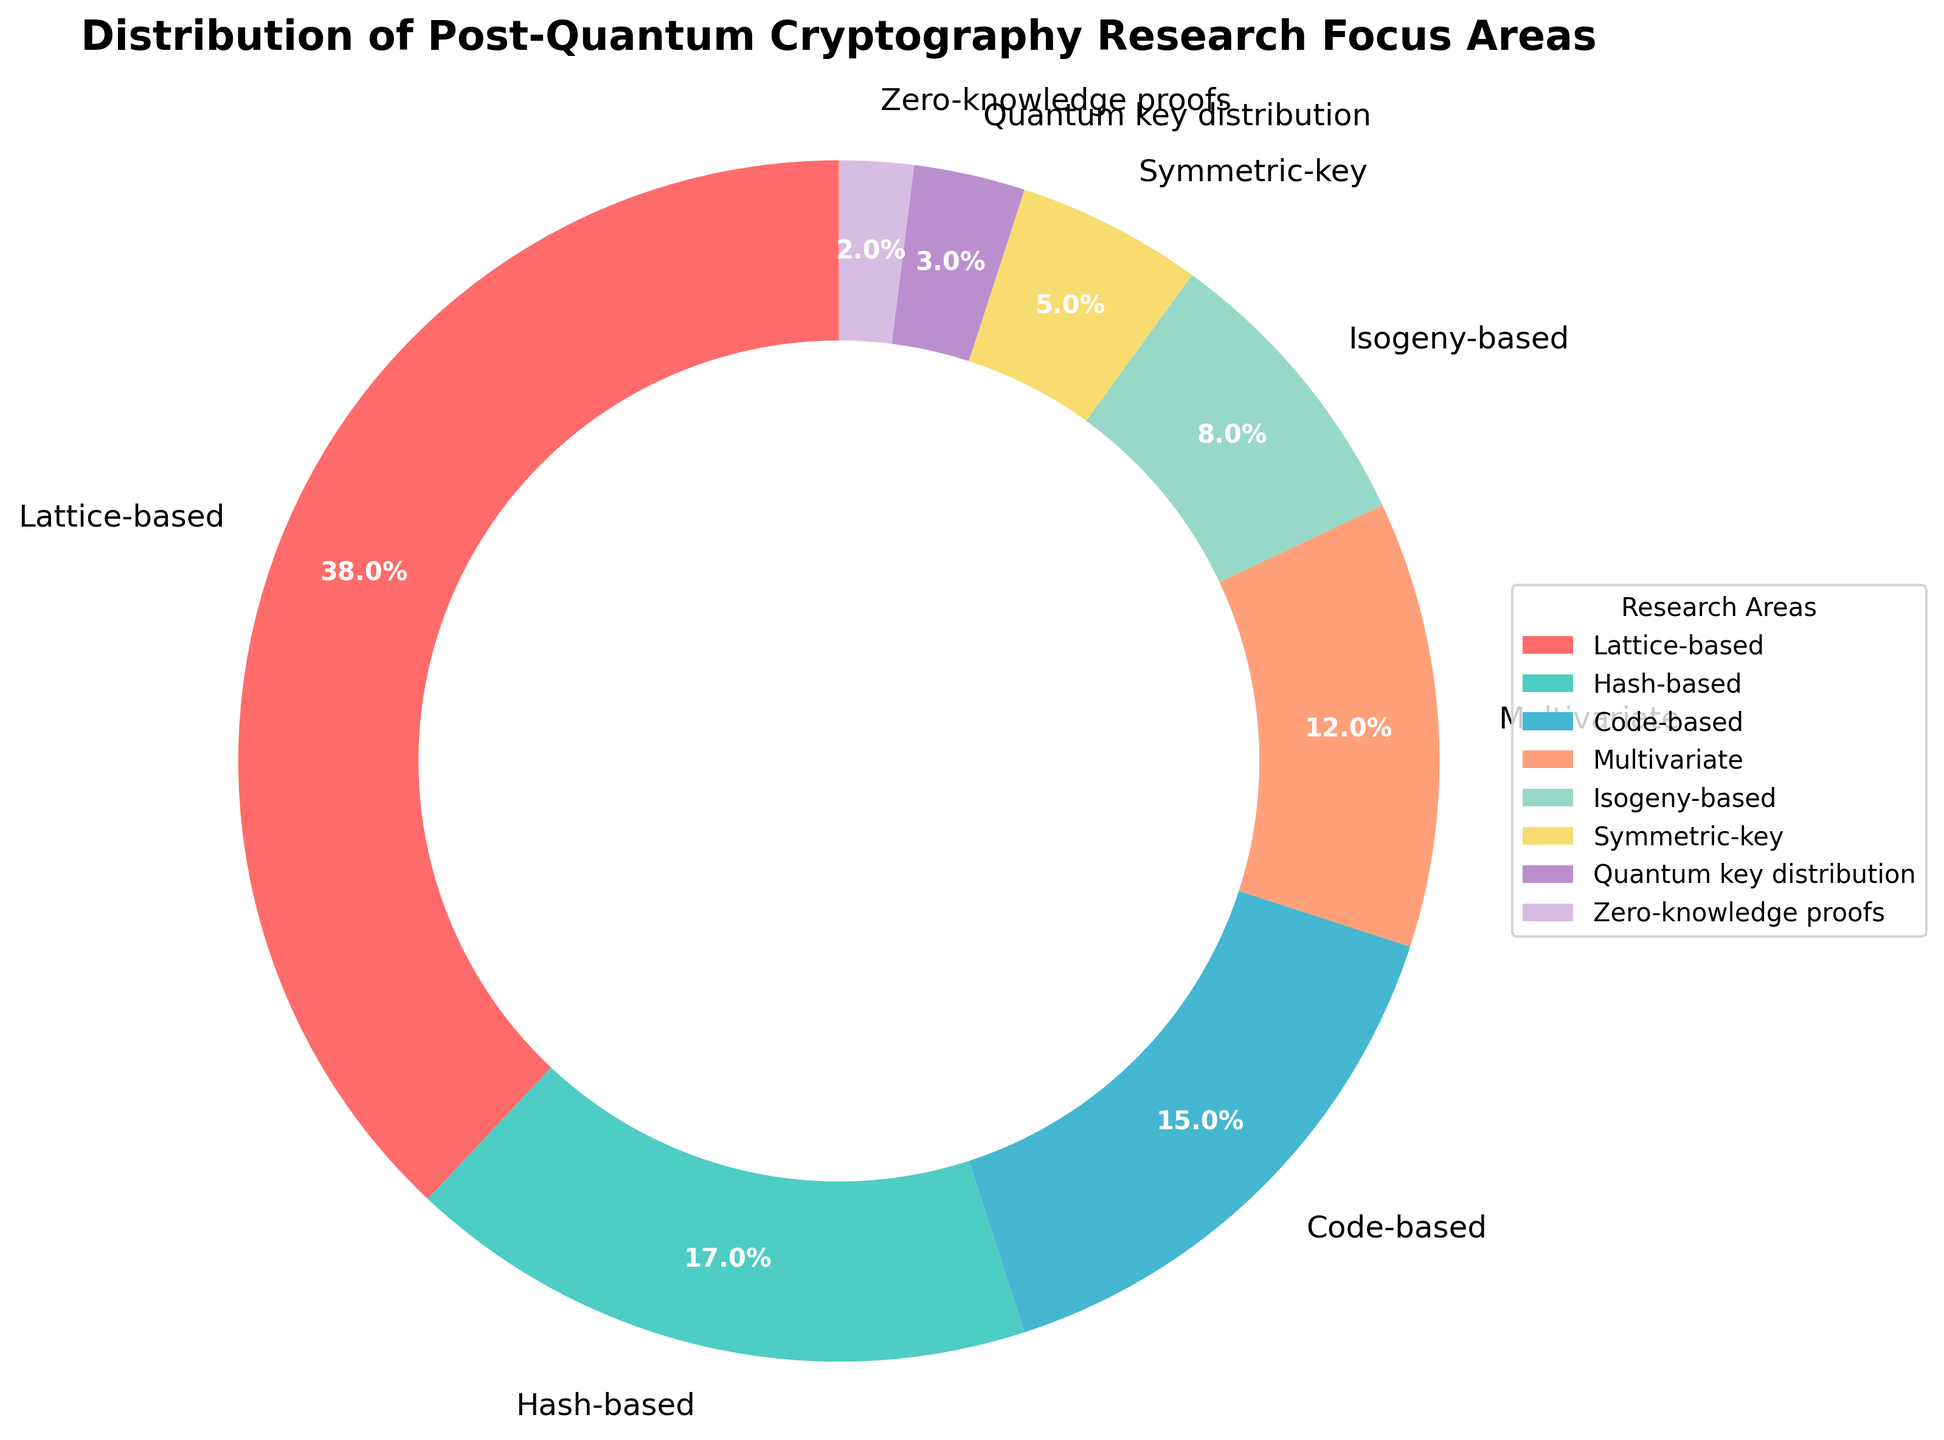What percentage of the research focus is dedicated to lattice-based cryptography? The pie chart shows that lattice-based cryptography accounts for 38% of the research focus.
Answer: 38% Which research area has a higher percentage focus, code-based or hash-based cryptography? By comparing the percentages, we see that hash-based cryptography (17%) has a higher percentage focus than code-based cryptography (15%).
Answer: Hash-based What is the combined research focus percentage of multivariate and isogeny-based approaches? The pie chart indicates that multivariate accounts for 12% and isogeny-based for 8%. Adding these together, 12% + 8% = 20%.
Answer: 20% Among the listed research areas, which has the lowest percentage focus? The pie chart shows that zero-knowledge proofs have the lowest percentage focus at 2%.
Answer: Zero-knowledge proofs Is the research focus on symmetric-key cryptography greater than on quantum key distribution? Comparing the percentages, symmetric-key cryptography has 5% focus, while quantum key distribution has 3%. Thus, symmetric-key is greater.
Answer: Yes What are the three research areas with the highest focus percentages? The pie chart lists lattice-based (38%), hash-based (17%), and code-based (15%) as the top three areas.
Answer: Lattice-based, Hash-based, Code-based How much more research focus does lattice-based cryptography have compared to isogeny-based? Lattice-based cryptography has 38% focus, whereas isogeny-based has 8%. The difference is 38% - 8% = 30%.
Answer: 30% Are there more research focus areas with percentages above 10% or below 10%? The areas above 10% are lattice-based (38%), hash-based (17%), code-based (15%), and multivariate (12%), totaling 4 areas. Those below 10% are isogeny-based (8%), symmetric-key (5%), quantum key distribution (3%), and zero-knowledge proofs (2%), also totaling 4 areas.
Answer: Equal What is the total percentage of research focus for symmetric-key cryptography, quantum key distribution, and zero-knowledge proofs combined? The pie chart shows percentages of 5% for symmetric-key, 3% for quantum key distribution, and 2% for zero-knowledge proofs. Summing these, 5% + 3% + 2% = 10%.
Answer: 10% Which color in the pie chart corresponds to the area with the highest research focus? The area with the highest research focus is lattice-based cryptography (38%), which is represented by red.
Answer: Red 